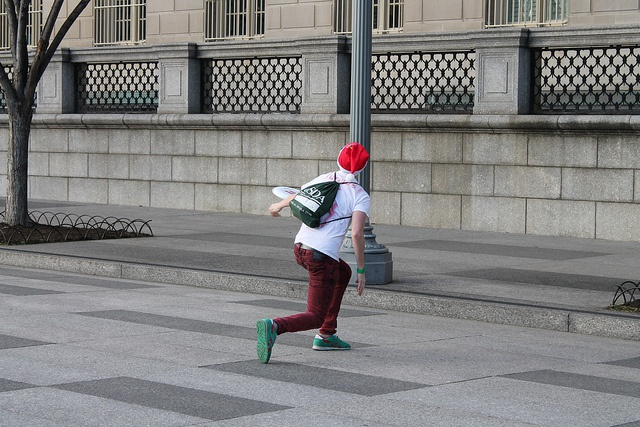Describe the objects in this image and their specific colors. I can see people in olive, black, lavender, gray, and darkgray tones, backpack in olive, black, lightgray, and teal tones, and frisbee in olive, lavender, darkgray, and gray tones in this image. 